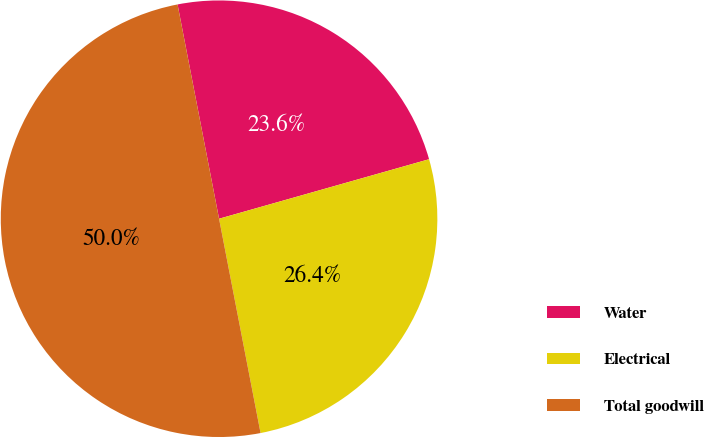Convert chart to OTSL. <chart><loc_0><loc_0><loc_500><loc_500><pie_chart><fcel>Water<fcel>Electrical<fcel>Total goodwill<nl><fcel>23.65%<fcel>26.35%<fcel>50.0%<nl></chart> 